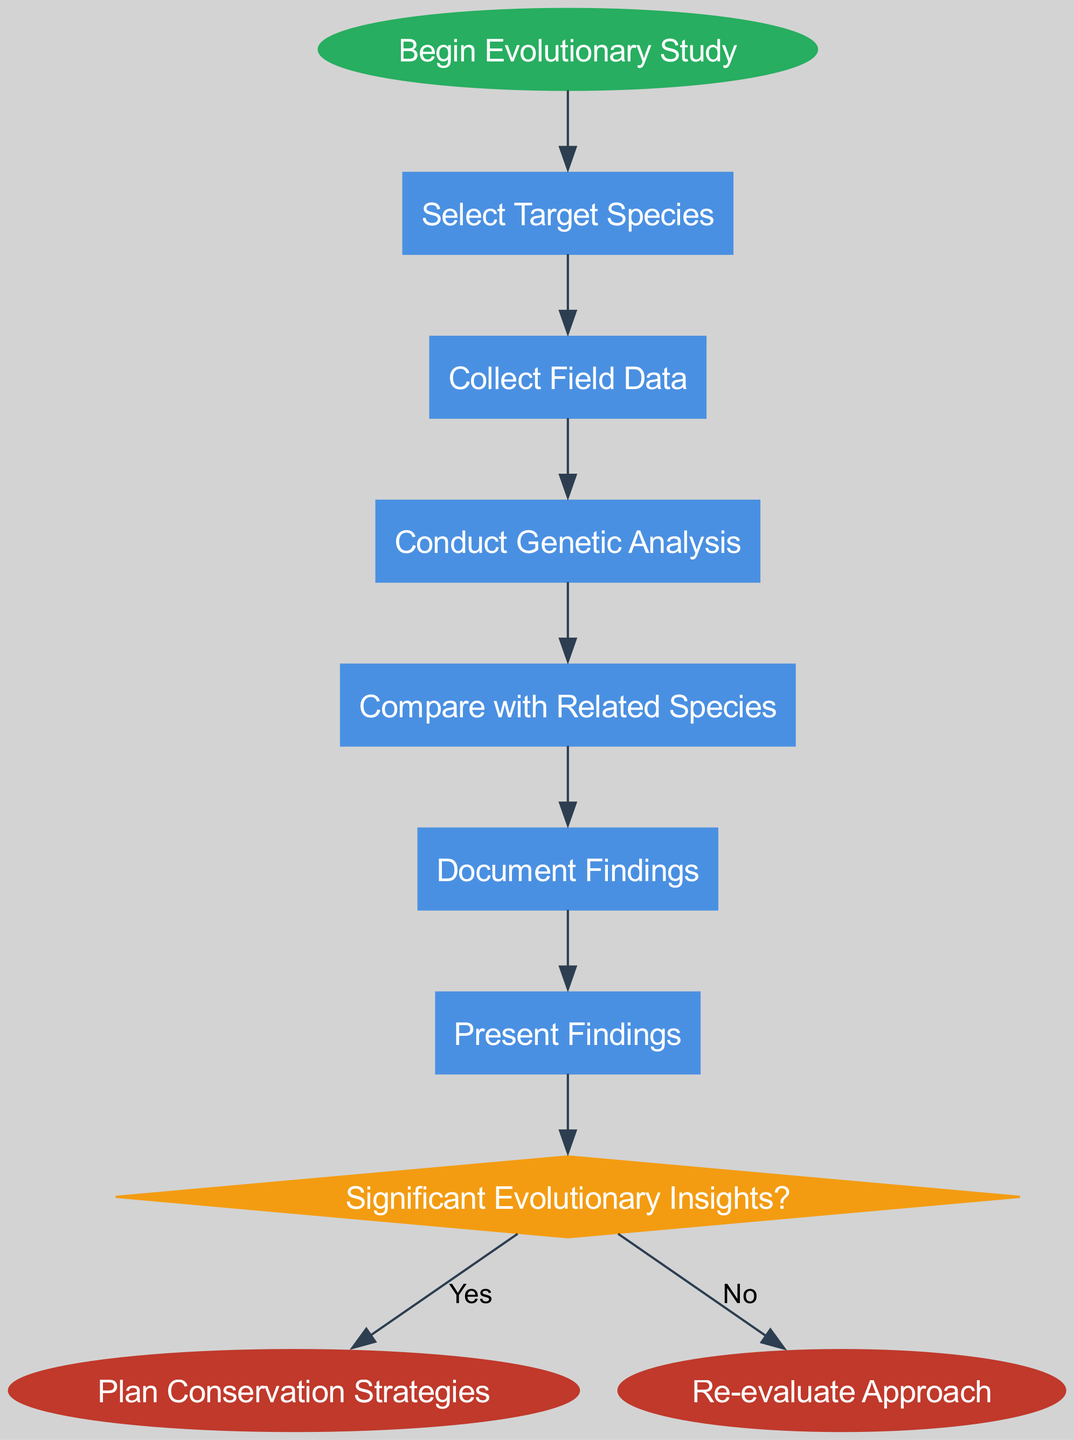What is the first activity in the diagram? The first activity, directly connected to the "Begin Evolutionary Study" start event, is "Select Target Species." This can be found as the first node listed after the start event in the sequence of activities.
Answer: Select Target Species How many activities are shown in the diagram? The diagram includes a total of 6 activities that are listed sequentially after the starting event and before the decision point. This is determined by counting the unique activity nodes present in the flow.
Answer: 6 What is the last decision point in the study? The last decision point in the study is "Significant Evolutionary Insights?" This decision occurs after all activities are completed, and it leads to different outcomes based on the insights gained.
Answer: Significant Evolutionary Insights? What happens if the outcome of the decision is 'Yes'? If the outcome of the decision is 'Yes', the next activity is "Plan Conservation Strategies." This indicates that significant insights were obtained, prompting a focus on conservation efforts.
Answer: Plan Conservation Strategies How many end events are there in the diagram? There are 2 end events in the diagram, which are connected to the decision point. Each end event corresponds to a different outcome based on the decision made, indicating alternative paths at the conclusion of the study.
Answer: 2 What is the second activity in the process? The second activity in the process, following the first one, is "Collect Field Data". This activity is directly connected to the first activity and represents the next step in the evolutionary study process.
Answer: Collect Field Data What is the relationship between "Conduct Genetic Analysis" and "Compare with Related Species"? The relationship is that "Conduct Genetic Analysis" leads directly into "Compare with Related Species." This shows a sequential flow where genetic information is first analyzed, and then it is compared with related species for further insights.
Answer: Sequential flow What action follows after "Document Findings"? After "Document Findings," the next action is the decision point "Significant Evolutionary Insights?" This indicates that documenting findings leads directly into evaluating the significance of those findings in relation to evolutionary insights.
Answer: Significant Evolutionary Insights? 